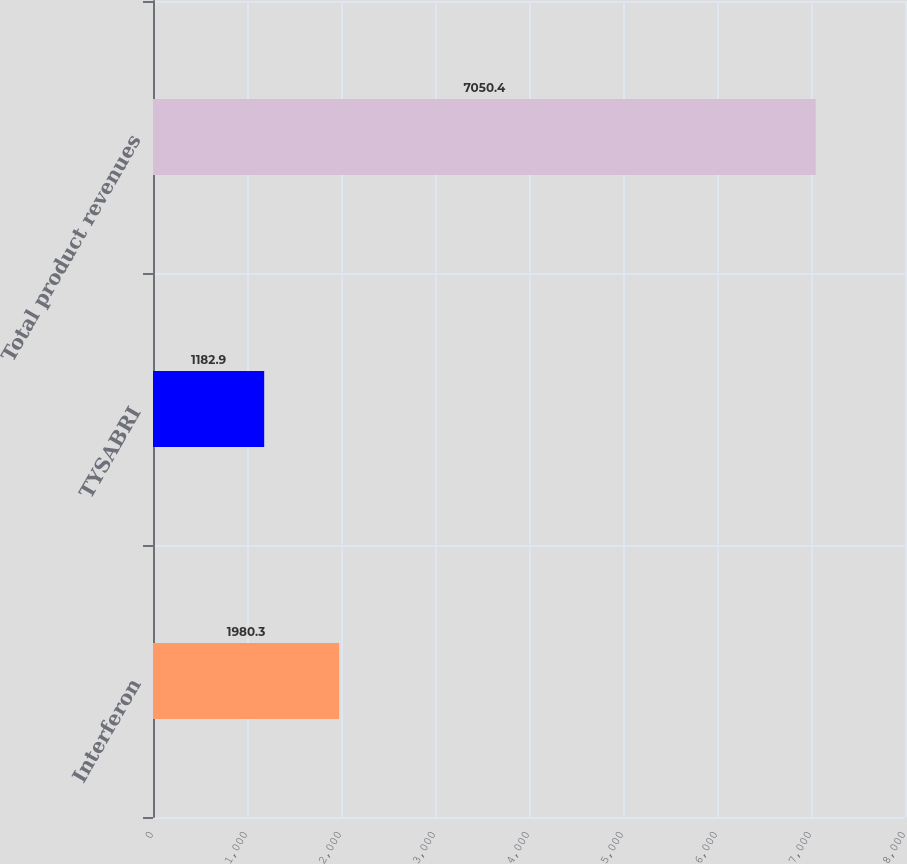Convert chart to OTSL. <chart><loc_0><loc_0><loc_500><loc_500><bar_chart><fcel>Interferon<fcel>TYSABRI<fcel>Total product revenues<nl><fcel>1980.3<fcel>1182.9<fcel>7050.4<nl></chart> 